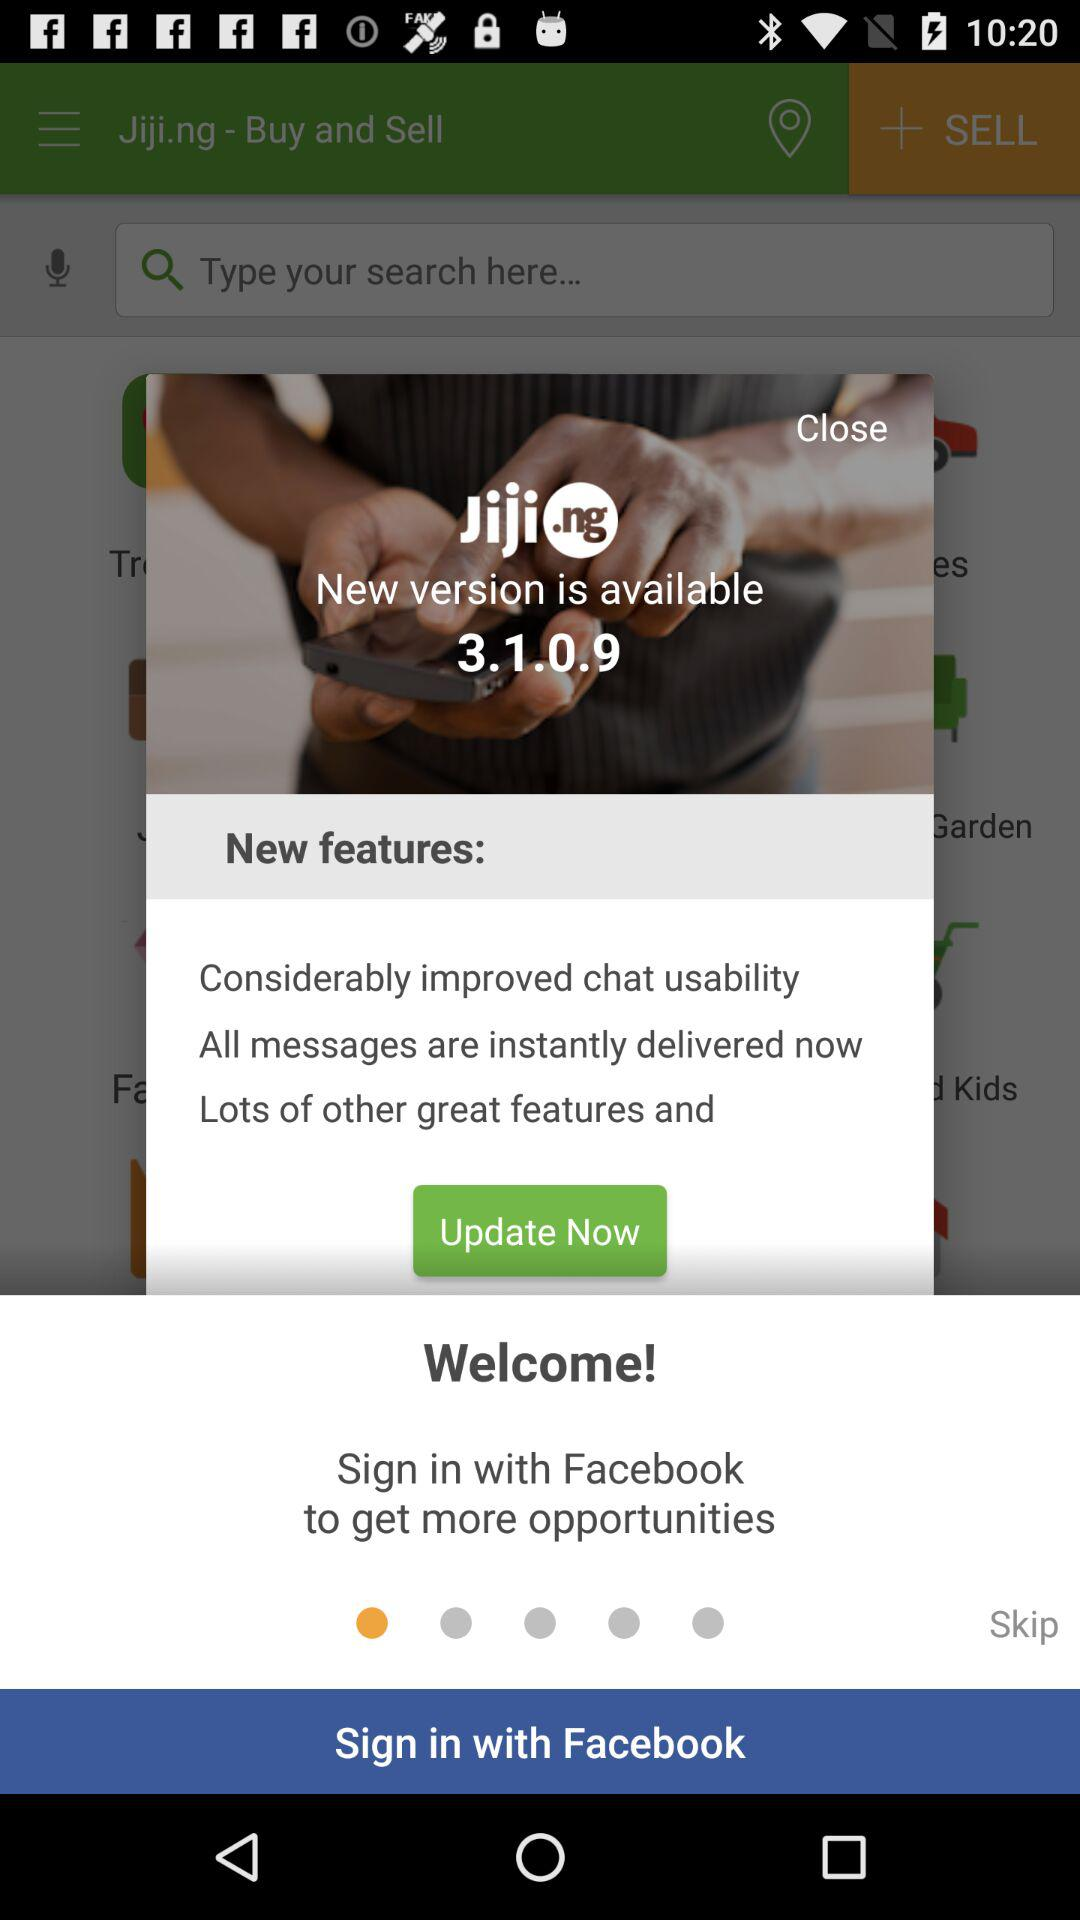What is the version of the application? The version of the application is 3.1.0.9. 